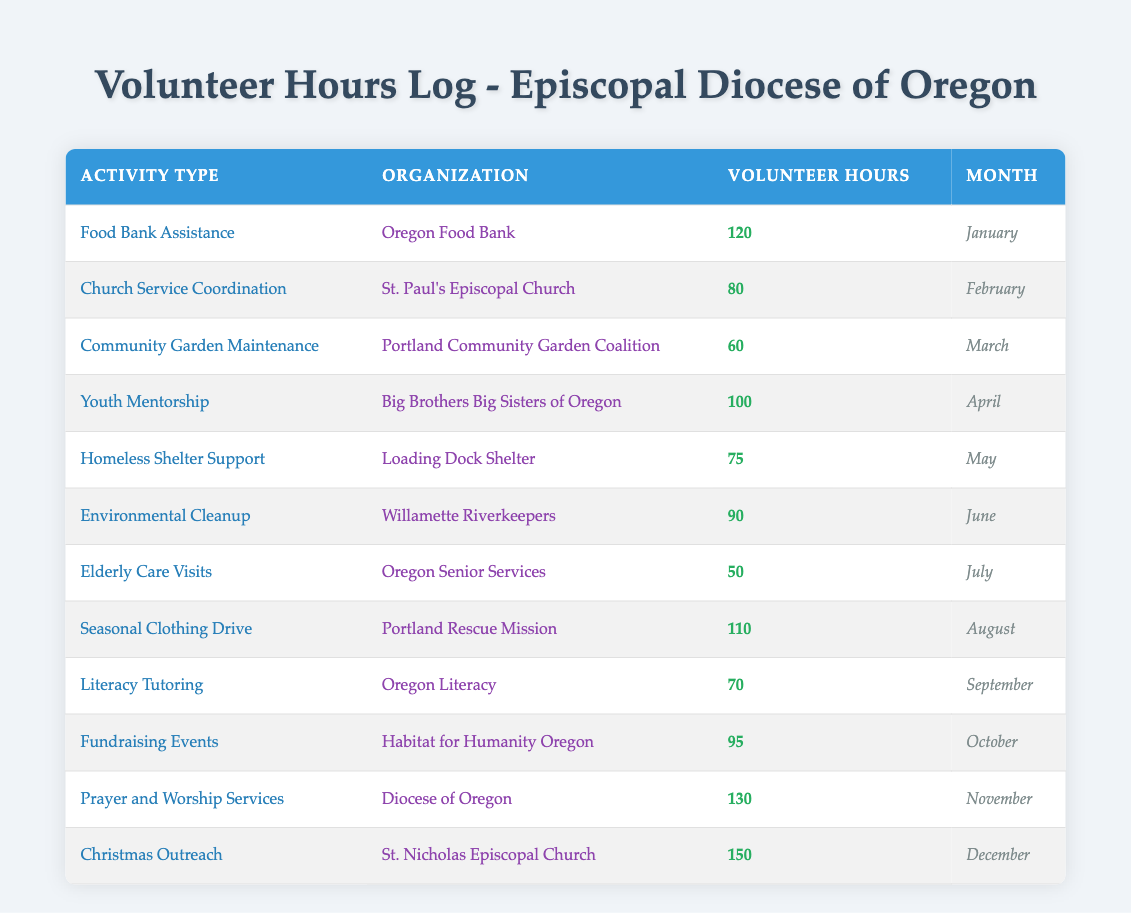What was the total number of volunteer hours logged for the "Christmas Outreach" activity? According to the table, the "Christmas Outreach" activity logged 150 volunteer hours in December.
Answer: 150 Which activity had the highest recorded volunteer hours? From the data presented, "Christmas Outreach" with 150 hours has the highest recorded volunteer hours.
Answer: Christmas Outreach How many volunteer hours were logged for activities related to church services in February and November? In February, "Church Service Coordination" logged 80 hours, and in November, "Prayer and Worship Services" logged 130 hours. The total is 80 + 130 = 210 hours.
Answer: 210 Did any activity log more than 100 volunteer hours? Yes, both "Christmas Outreach" (150 hours) and "Prayer and Worship Services" (130 hours) logged more than 100 hours each.
Answer: Yes What is the difference in volunteer hours between the "Elderly Care Visits" and "Community Garden Maintenance" activities? "Elderly Care Visits" logged 50 hours and "Community Garden Maintenance" logged 60 hours. The difference is 60 - 50 = 10 hours.
Answer: 10 What were the volunteer hours logged for "Environmental Cleanup" and "Fundraising Events"? "Environmental Cleanup" logged 90 hours, while "Fundraising Events" logged 95 hours. Together, they totaled 90 + 95 = 185 hours.
Answer: 185 Is there any activity recorded in July? Yes, the "Elderly Care Visits" activity was logged in July with 50 hours.
Answer: Yes What is the average number of volunteer hours logged across all activities for the year? Summing all volunteer hours gives 120 + 80 + 60 + 100 + 75 + 90 + 50 + 110 + 70 + 95 + 130 + 150 = 1,200 hours. There are 12 activities, so the average is 1,200 / 12 = 100 hours.
Answer: 100 Which organization received the most volunteer support in terms of total hours logged? "St. Nicholas Episcopal Church" with "Christmas Outreach" logged the highest at 150 hours of support.
Answer: St. Nicholas Episcopal Church In which month was the least amount of volunteer hours logged, and what was the activity? The least logged hours were in July, with "Elderly Care Visits" at 50 hours.
Answer: July, Elderly Care Visits 